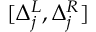<formula> <loc_0><loc_0><loc_500><loc_500>[ \Delta _ { j } ^ { L } , \Delta _ { j } ^ { R } ]</formula> 